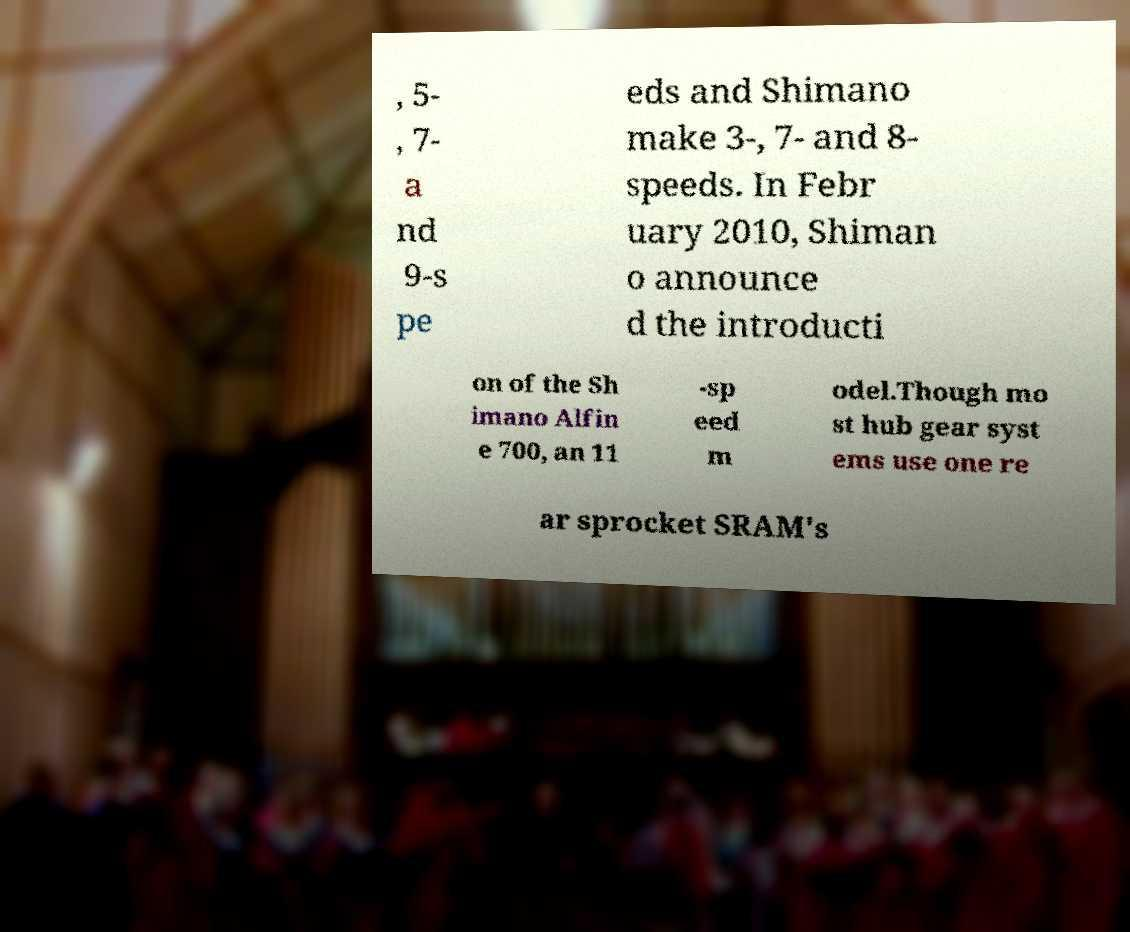Can you accurately transcribe the text from the provided image for me? , 5- , 7- a nd 9-s pe eds and Shimano make 3-, 7- and 8- speeds. In Febr uary 2010, Shiman o announce d the introducti on of the Sh imano Alfin e 700, an 11 -sp eed m odel.Though mo st hub gear syst ems use one re ar sprocket SRAM's 